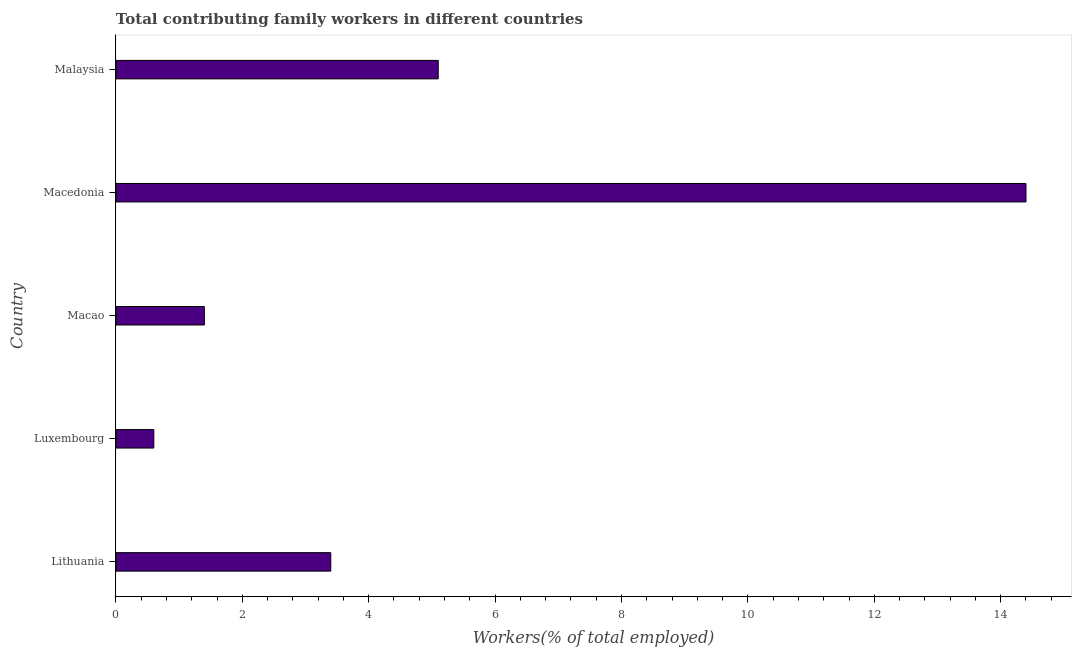Does the graph contain grids?
Your answer should be compact. No. What is the title of the graph?
Give a very brief answer. Total contributing family workers in different countries. What is the label or title of the X-axis?
Offer a very short reply. Workers(% of total employed). What is the contributing family workers in Malaysia?
Your answer should be very brief. 5.1. Across all countries, what is the maximum contributing family workers?
Provide a short and direct response. 14.4. Across all countries, what is the minimum contributing family workers?
Provide a succinct answer. 0.6. In which country was the contributing family workers maximum?
Give a very brief answer. Macedonia. In which country was the contributing family workers minimum?
Your answer should be compact. Luxembourg. What is the sum of the contributing family workers?
Your answer should be compact. 24.9. What is the difference between the contributing family workers in Luxembourg and Macao?
Your response must be concise. -0.8. What is the average contributing family workers per country?
Give a very brief answer. 4.98. What is the median contributing family workers?
Make the answer very short. 3.4. In how many countries, is the contributing family workers greater than 12.4 %?
Your answer should be compact. 1. What is the ratio of the contributing family workers in Lithuania to that in Macedonia?
Make the answer very short. 0.24. Is the contributing family workers in Lithuania less than that in Macedonia?
Give a very brief answer. Yes. Is the sum of the contributing family workers in Lithuania and Macao greater than the maximum contributing family workers across all countries?
Offer a terse response. No. Are all the bars in the graph horizontal?
Provide a short and direct response. Yes. What is the Workers(% of total employed) in Lithuania?
Give a very brief answer. 3.4. What is the Workers(% of total employed) of Luxembourg?
Your response must be concise. 0.6. What is the Workers(% of total employed) in Macao?
Provide a short and direct response. 1.4. What is the Workers(% of total employed) of Macedonia?
Keep it short and to the point. 14.4. What is the Workers(% of total employed) in Malaysia?
Offer a terse response. 5.1. What is the difference between the Workers(% of total employed) in Lithuania and Luxembourg?
Your response must be concise. 2.8. What is the difference between the Workers(% of total employed) in Lithuania and Malaysia?
Your answer should be very brief. -1.7. What is the difference between the Workers(% of total employed) in Luxembourg and Macao?
Your response must be concise. -0.8. What is the difference between the Workers(% of total employed) in Luxembourg and Macedonia?
Provide a succinct answer. -13.8. What is the difference between the Workers(% of total employed) in Luxembourg and Malaysia?
Provide a succinct answer. -4.5. What is the difference between the Workers(% of total employed) in Macao and Macedonia?
Your answer should be compact. -13. What is the difference between the Workers(% of total employed) in Macao and Malaysia?
Offer a terse response. -3.7. What is the ratio of the Workers(% of total employed) in Lithuania to that in Luxembourg?
Your answer should be very brief. 5.67. What is the ratio of the Workers(% of total employed) in Lithuania to that in Macao?
Offer a very short reply. 2.43. What is the ratio of the Workers(% of total employed) in Lithuania to that in Macedonia?
Offer a very short reply. 0.24. What is the ratio of the Workers(% of total employed) in Lithuania to that in Malaysia?
Provide a short and direct response. 0.67. What is the ratio of the Workers(% of total employed) in Luxembourg to that in Macao?
Your response must be concise. 0.43. What is the ratio of the Workers(% of total employed) in Luxembourg to that in Macedonia?
Offer a terse response. 0.04. What is the ratio of the Workers(% of total employed) in Luxembourg to that in Malaysia?
Provide a short and direct response. 0.12. What is the ratio of the Workers(% of total employed) in Macao to that in Macedonia?
Your response must be concise. 0.1. What is the ratio of the Workers(% of total employed) in Macao to that in Malaysia?
Make the answer very short. 0.28. What is the ratio of the Workers(% of total employed) in Macedonia to that in Malaysia?
Your response must be concise. 2.82. 